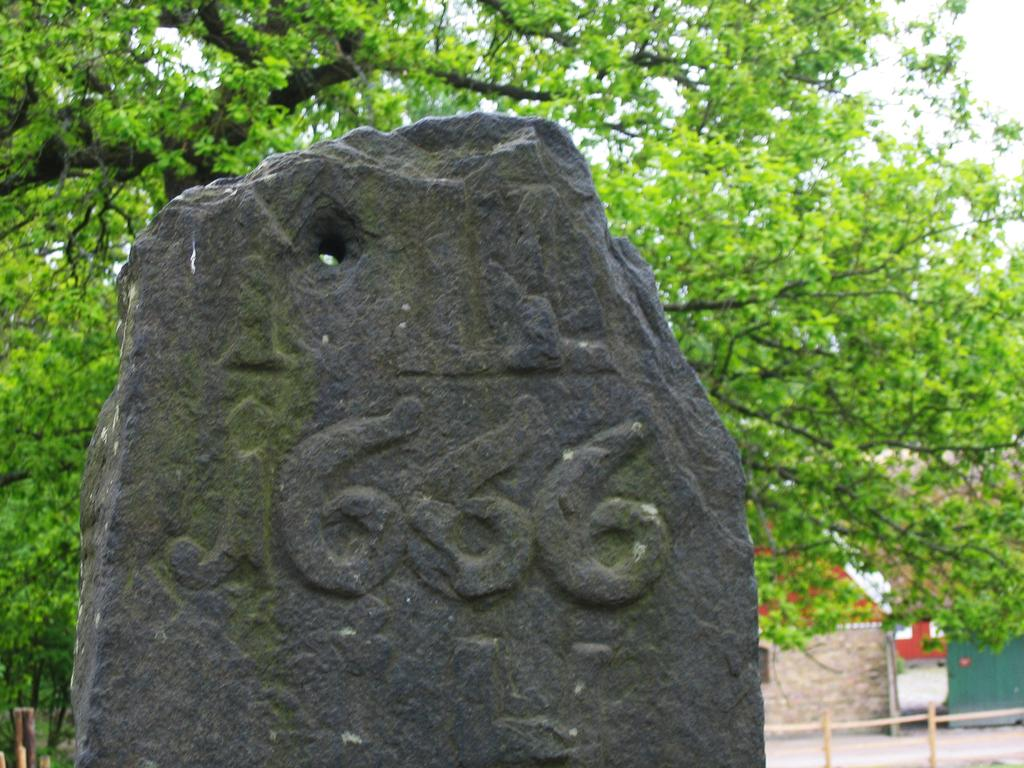What object can be seen in the image? There is a stone in the image. What structure is visible in the image? There is a wall in the image. What type of vegetation is in the background of the image? There are trees in the background of the image. What part of the natural environment is visible in the image? The sky is visible in the background of the image. Can you see any milk coming out of the stone in the image? There is no milk present in the image, and the stone is not producing any liquid. Are there any bees flying around the stone in the image? There is no mention of bees or any other insects in the image; it only features a stone and a wall. 